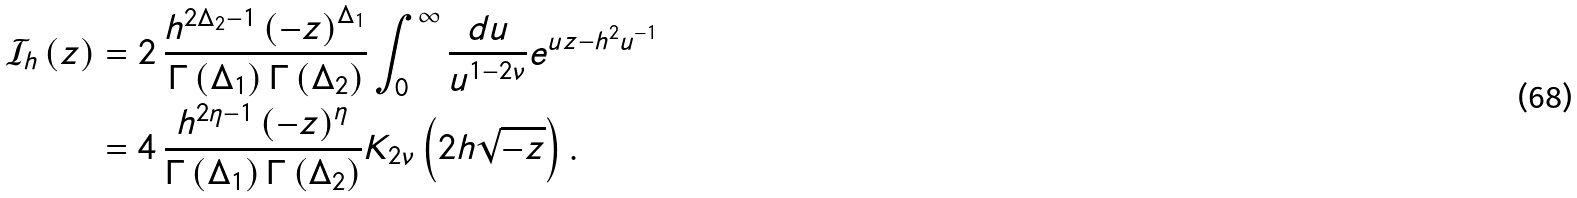<formula> <loc_0><loc_0><loc_500><loc_500>\mathcal { I } _ { h } \left ( z \right ) & = 2 \, \frac { h ^ { 2 \Delta _ { 2 } - 1 } \left ( - z \right ) ^ { \Delta _ { 1 } } } { \Gamma \left ( \Delta _ { 1 } \right ) \Gamma \left ( \Delta _ { 2 } \right ) } \int _ { 0 } ^ { \infty } \frac { d u } { u ^ { 1 - 2 \nu } } e ^ { u z - h ^ { 2 } u ^ { - 1 } } \\ & = 4 \, \frac { h ^ { 2 \eta - 1 } \left ( - z \right ) ^ { \eta } } { \Gamma \left ( \Delta _ { 1 } \right ) \Gamma \left ( \Delta _ { 2 } \right ) } K _ { 2 \nu } \left ( 2 h \sqrt { - z } \right ) .</formula> 